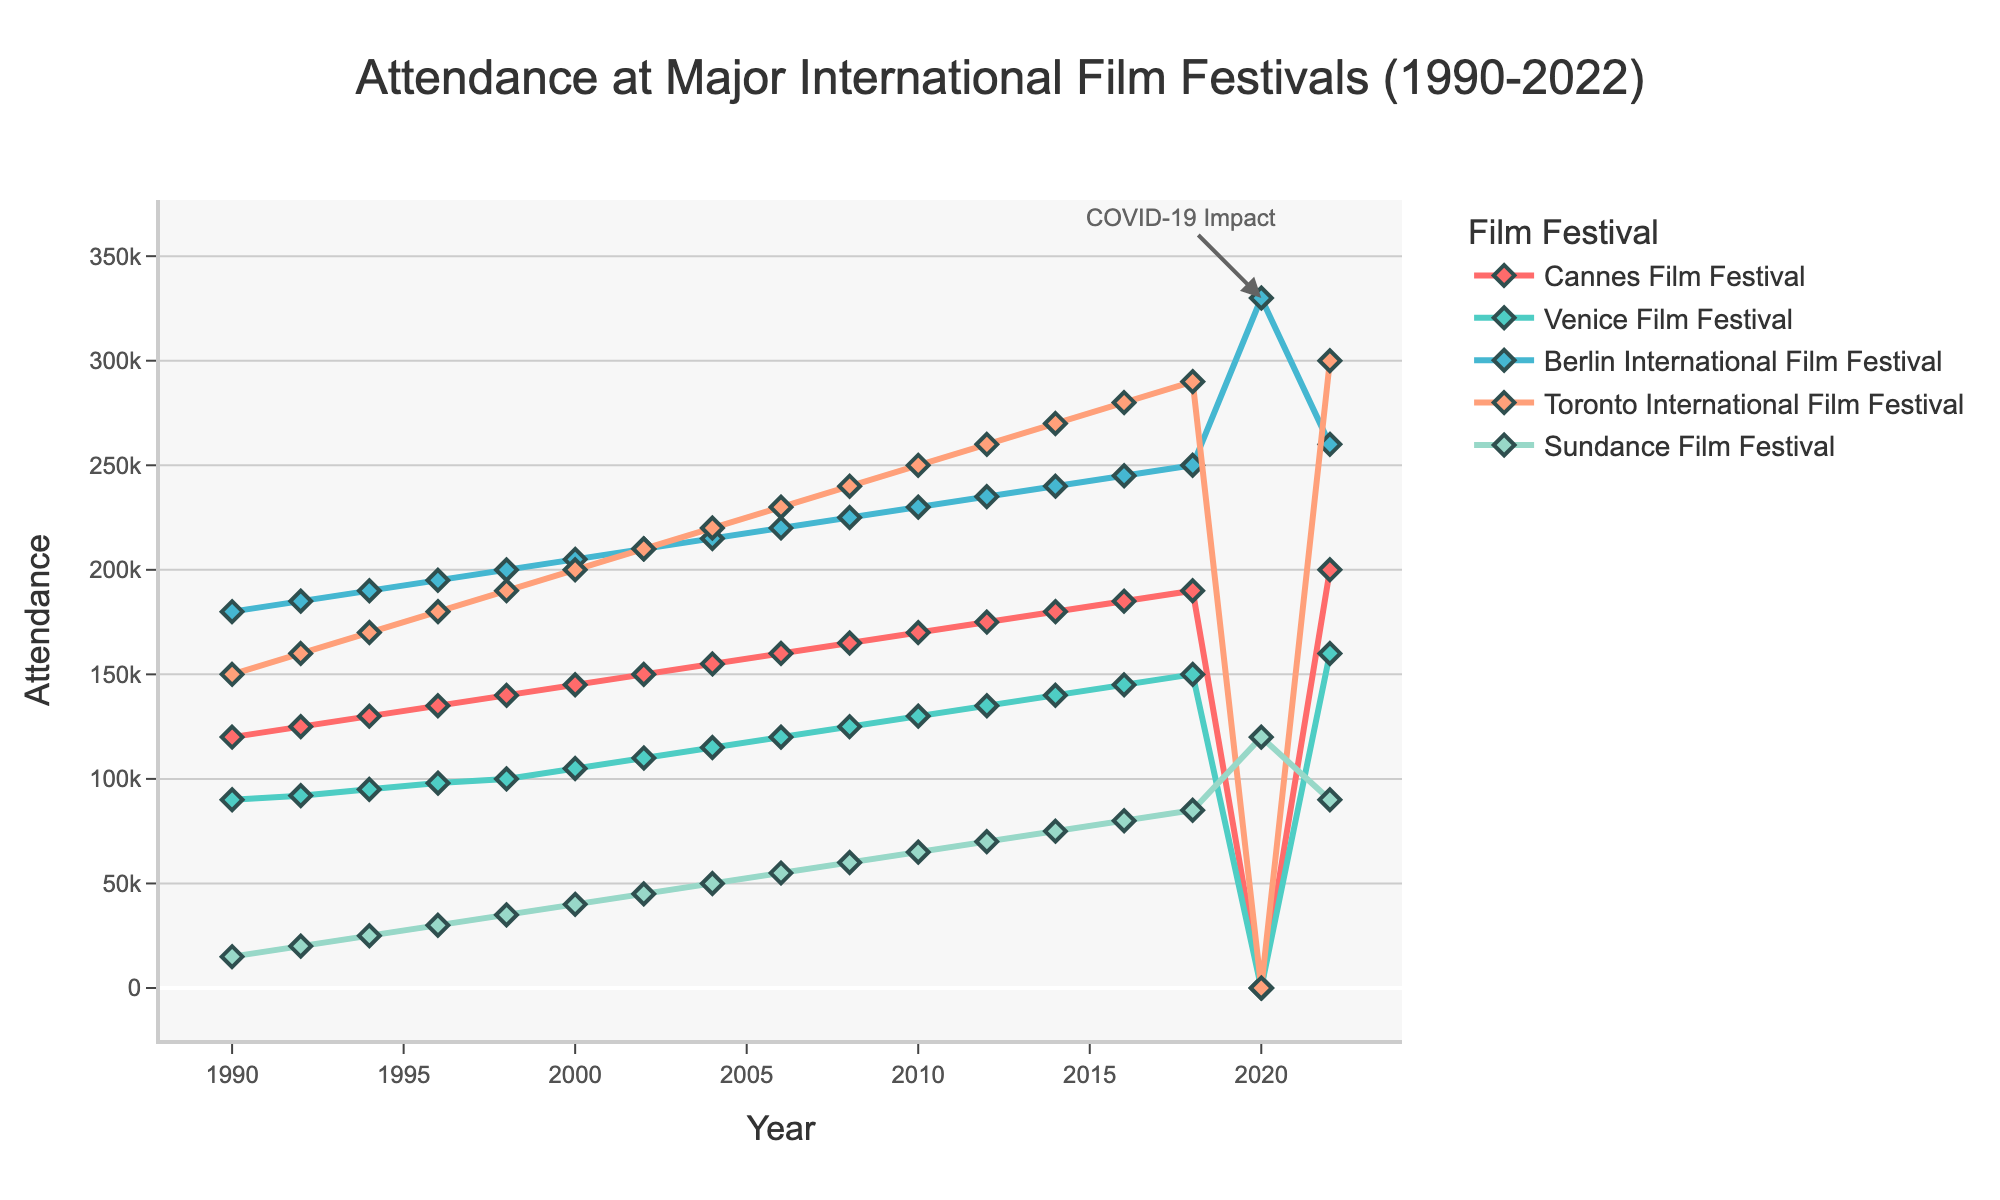What year did the attendance at the Berlin International Film Festival peak? The figure shows a significant spike in attendance for the Berlin International Film Festival in the year 2020, reaching its highest point.
Answer: 2020 Which film festival had the highest attendance in 2022? By looking at the end of each line in the figure for the year 2022, the Toronto International Film Festival had the highest attendance.
Answer: Toronto International Film Festival By how much did the attendance at the Cannes Film Festival grow from 1990 to 2018? To find the growth, subtract the attendance in 1990 (120,000) from the attendance in 2018 (190,000): 190,000 - 120,000 = 70,000.
Answer: 70,000 Which festival showed the least attendance in 1990? Observing the data points for 1990, the Sundance Film Festival had the least attendance at 15,000.
Answer: Sundance Film Festival How did the COVID-19 pandemic impact the attendance trends in 2020 for the festivals? During 2020, the Cannes Film Festival, Venice Film Festival, and Toronto International Film Festival had a sharp drop to zero, whereas the Sundance Film Festival increased to 120,000, and the Berlin International Film Festival peaked at 330,000.
Answer: Cannes, Venice, and Toronto dropped to zero; Sundance increased; Berlin peaked What two festivals had an equal attendance in 2000, and what was that attendance? From the chart, the Cannes Film Festival and the Berlin International Film Festival both had an attendance of 145,000 in the year 2000.
Answer: Cannes and Berlin, 145,000 By how much did the attendance at the Sundance Film Festival change from 2008 to 2022? To find the change, subtract the attendance in 2008 (60,000) from the attendance in 2022 (90,000): 90,000 - 60,000 = 30,000.
Answer: 30,000 Compare the trends in attendance growth between the Toronto International Film Festival and the Venice Film Festival. The Toronto International Film Festival consistently increased and ended at 300,000 in 2022. The Venice Film Festival also increased but more moderately, reaching 160,000 in 2022. Toronto grew faster than Venice.
Answer: Toronto grew faster Which festival had the most significant drop in attendance due to the COVID-19 impact in 2020? Observing the pre-2020 and 2020 attendance, the Cannes Film Festival dropped from 190,000 (2018) to zero, representing the most notable reduction.
Answer: Cannes Film Festival 